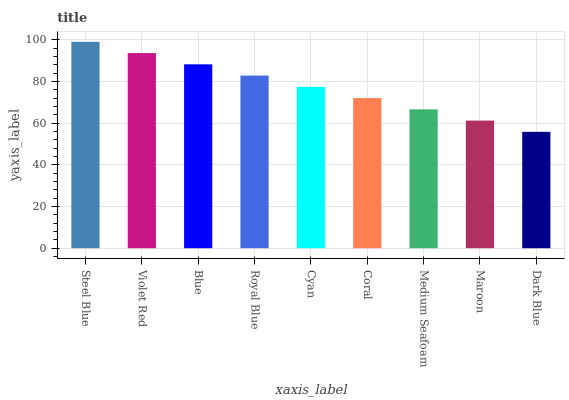Is Dark Blue the minimum?
Answer yes or no. Yes. Is Steel Blue the maximum?
Answer yes or no. Yes. Is Violet Red the minimum?
Answer yes or no. No. Is Violet Red the maximum?
Answer yes or no. No. Is Steel Blue greater than Violet Red?
Answer yes or no. Yes. Is Violet Red less than Steel Blue?
Answer yes or no. Yes. Is Violet Red greater than Steel Blue?
Answer yes or no. No. Is Steel Blue less than Violet Red?
Answer yes or no. No. Is Cyan the high median?
Answer yes or no. Yes. Is Cyan the low median?
Answer yes or no. Yes. Is Dark Blue the high median?
Answer yes or no. No. Is Medium Seafoam the low median?
Answer yes or no. No. 